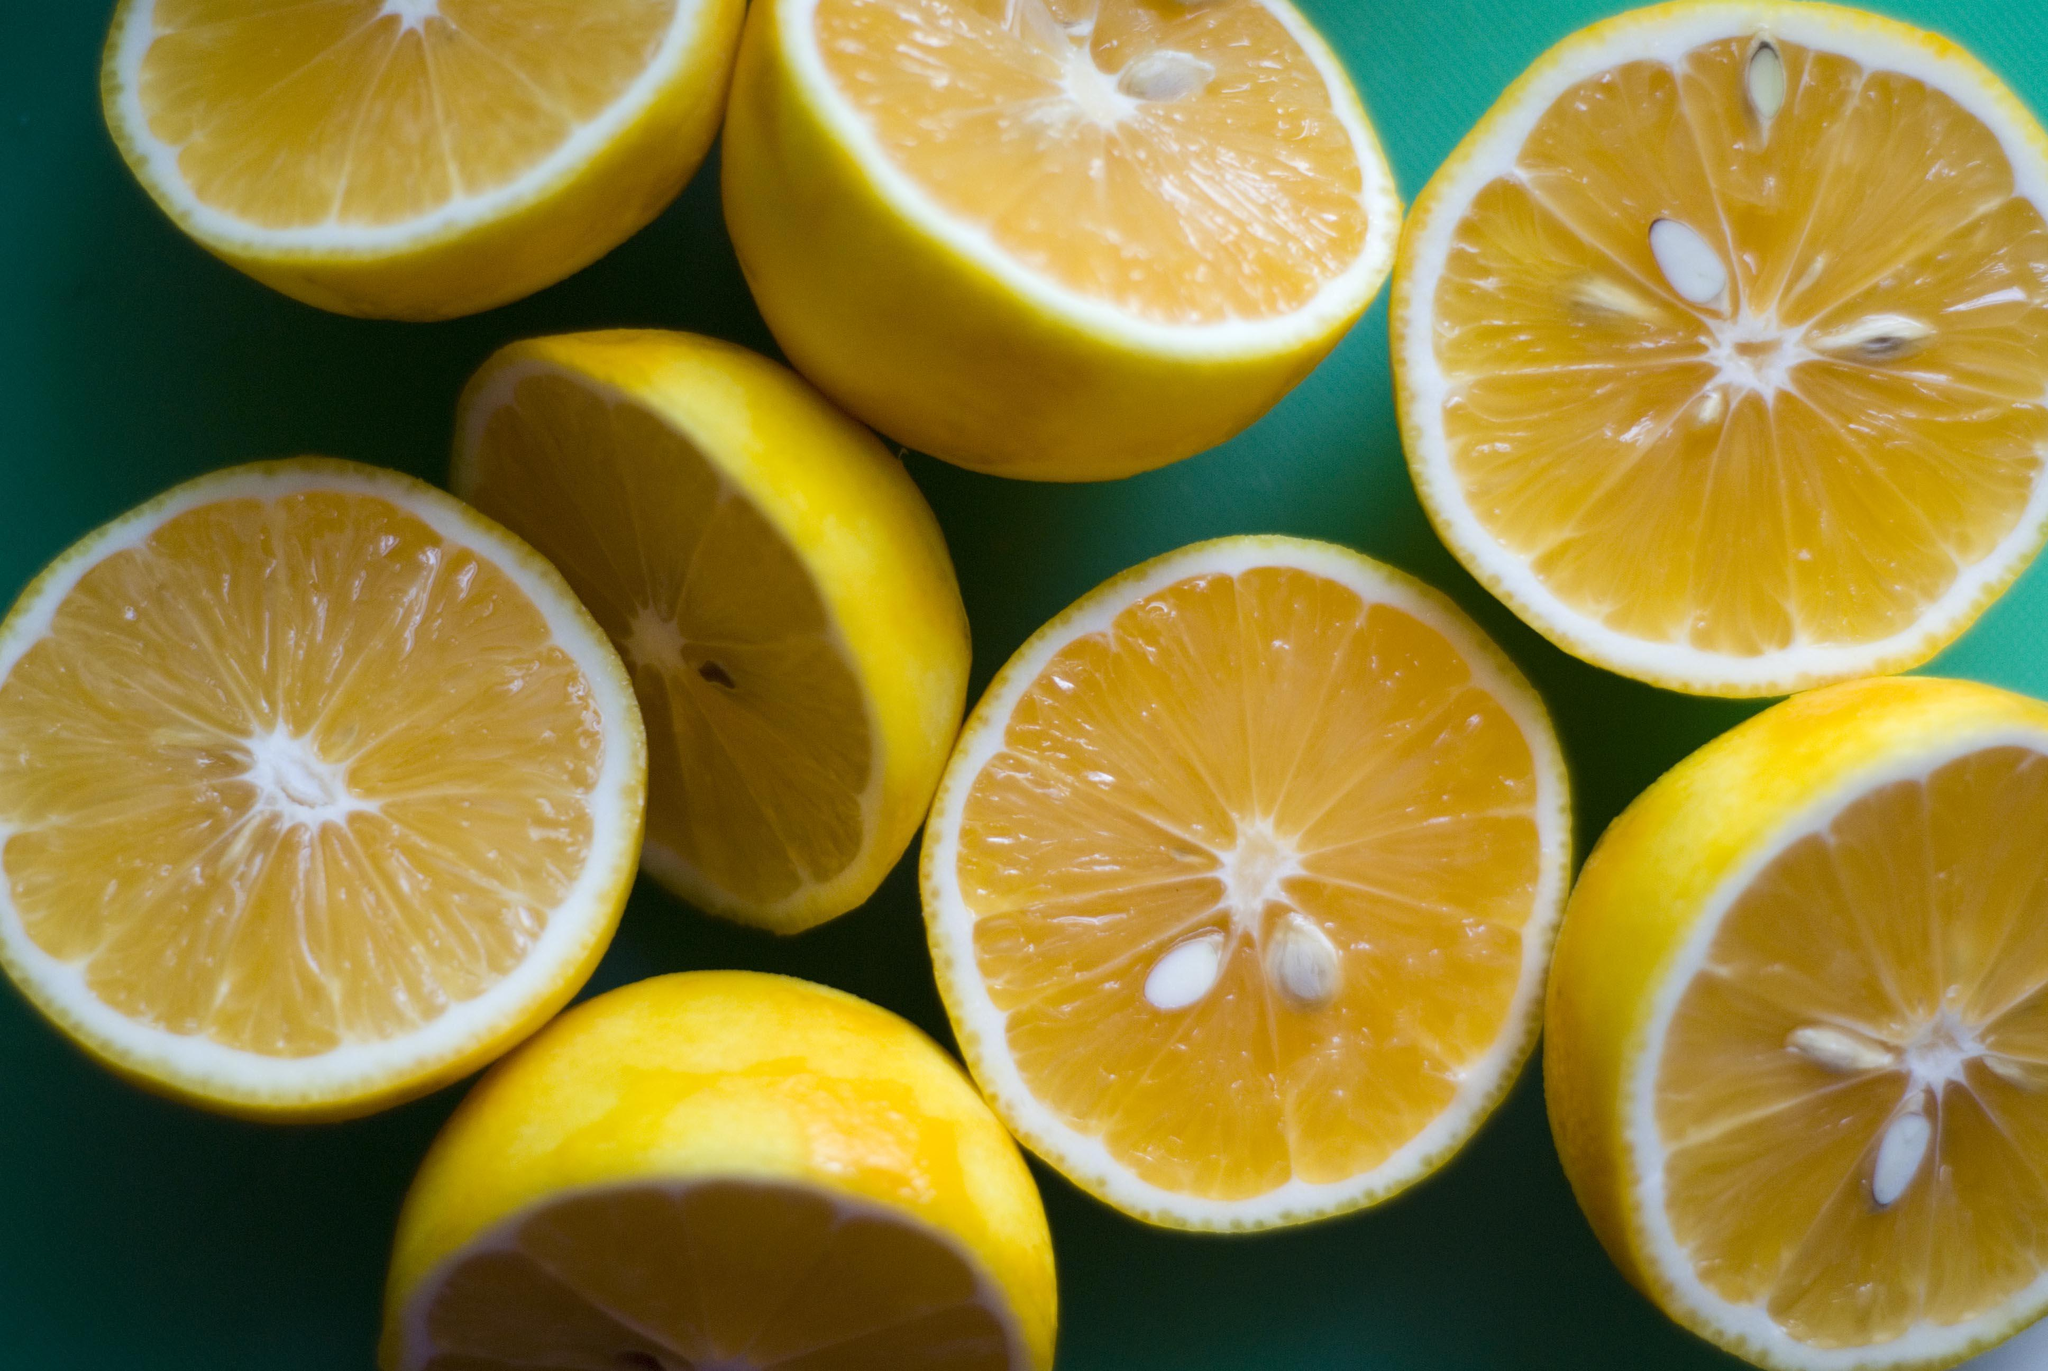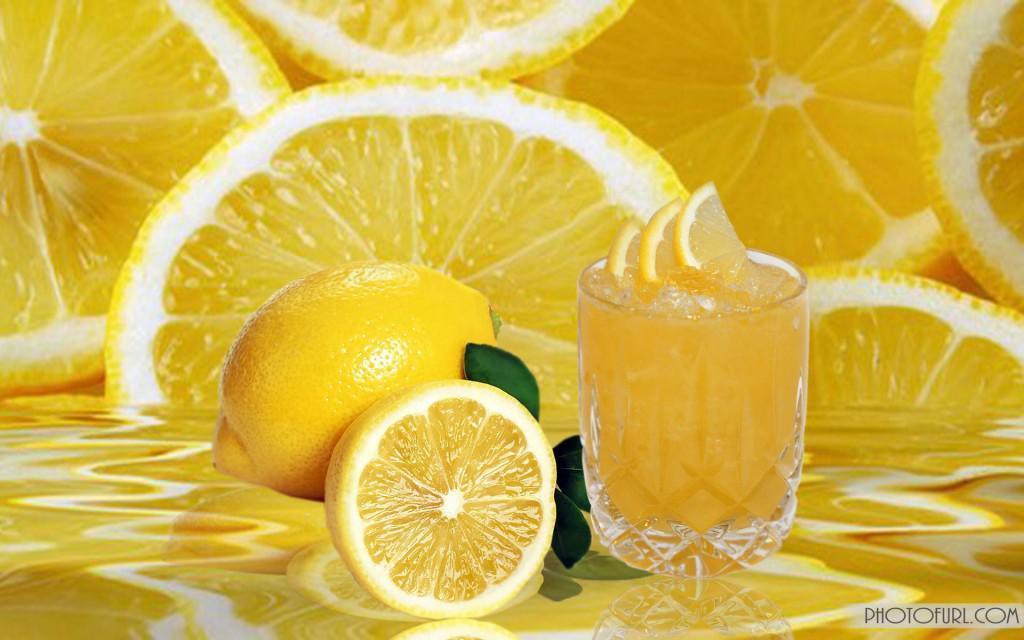The first image is the image on the left, the second image is the image on the right. Examine the images to the left and right. Is the description "The lemon slices are on top of meat in at least one of the images." accurate? Answer yes or no. No. The first image is the image on the left, the second image is the image on the right. For the images shown, is this caption "There is a whole lemon in exactly one of the images." true? Answer yes or no. Yes. 